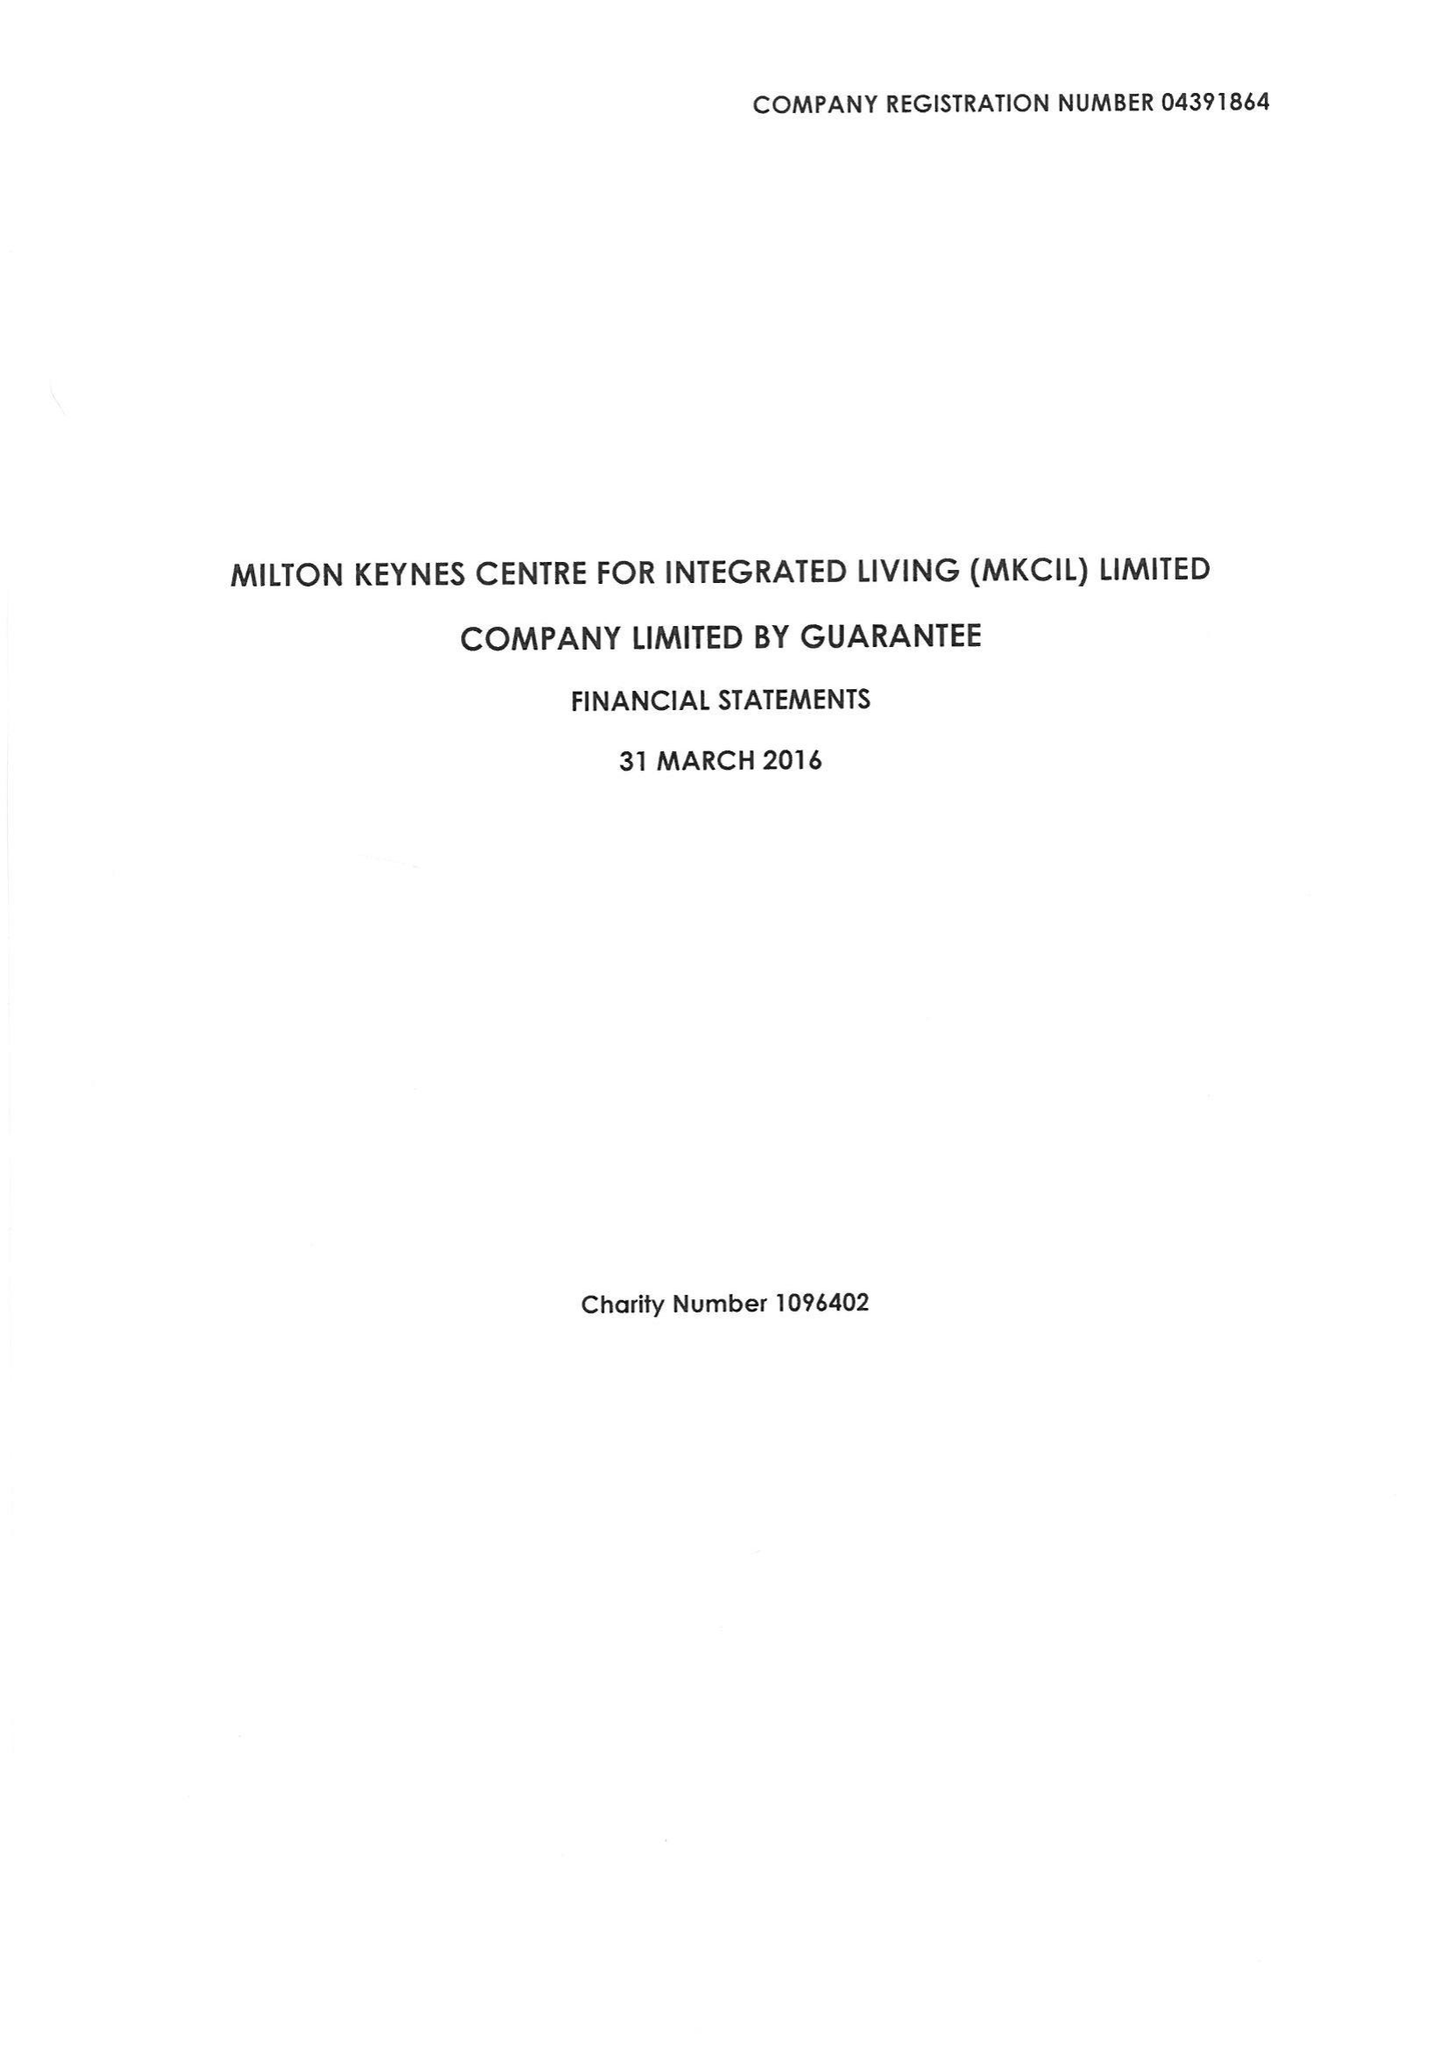What is the value for the report_date?
Answer the question using a single word or phrase. 2016-03-31 